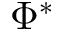Convert formula to latex. <formula><loc_0><loc_0><loc_500><loc_500>\Phi ^ { * }</formula> 